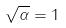<formula> <loc_0><loc_0><loc_500><loc_500>\sqrt { \alpha } = 1</formula> 